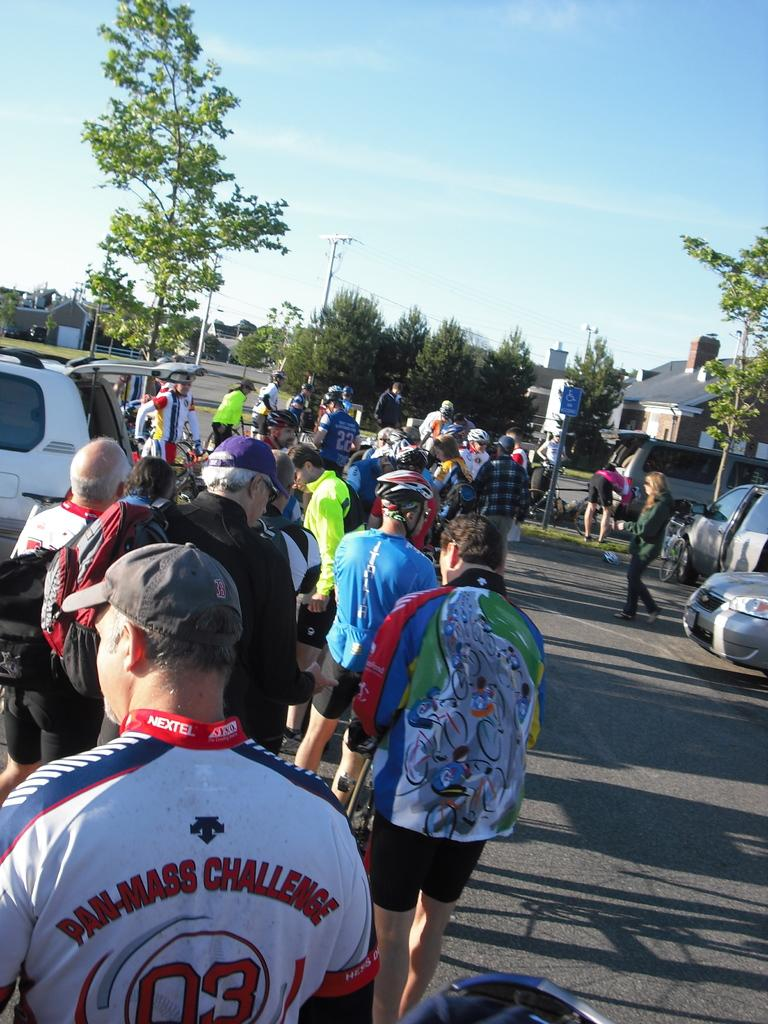How many people are in the image? There is a group of people in the image. Where are the people located? The people are standing on the street. What can be seen in the background around the people? There are trees around the people. What else is visible in the image besides the people and trees? There are cars visible in the image. What type of ornament is hanging from the trees in the image? There is no ornament hanging from the trees in the image; only the people, street, trees, and cars are present. 